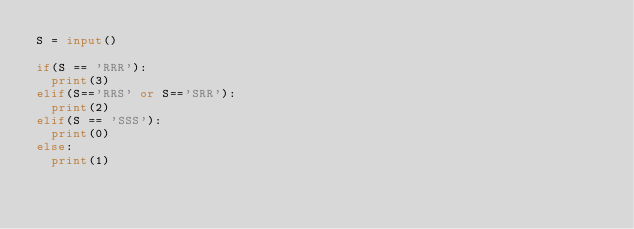<code> <loc_0><loc_0><loc_500><loc_500><_Python_>S = input()

if(S == 'RRR'):
  print(3)
elif(S=='RRS' or S=='SRR'):
  print(2)
elif(S == 'SSS'):
  print(0)
else:
  print(1)</code> 